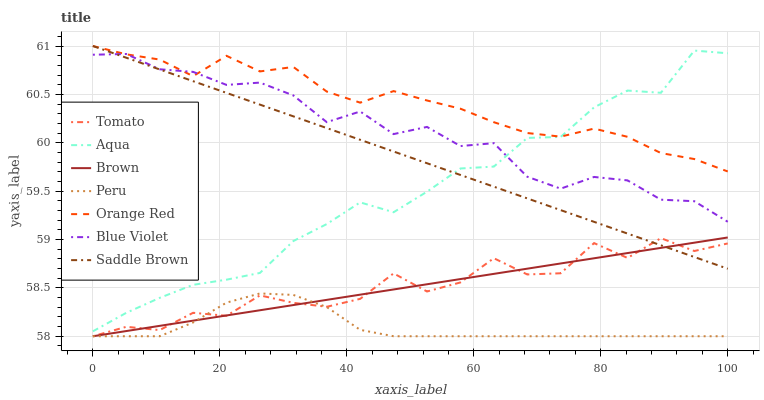Does Peru have the minimum area under the curve?
Answer yes or no. Yes. Does Orange Red have the maximum area under the curve?
Answer yes or no. Yes. Does Brown have the minimum area under the curve?
Answer yes or no. No. Does Brown have the maximum area under the curve?
Answer yes or no. No. Is Brown the smoothest?
Answer yes or no. Yes. Is Tomato the roughest?
Answer yes or no. Yes. Is Aqua the smoothest?
Answer yes or no. No. Is Aqua the roughest?
Answer yes or no. No. Does Tomato have the lowest value?
Answer yes or no. Yes. Does Aqua have the lowest value?
Answer yes or no. No. Does Orange Red have the highest value?
Answer yes or no. Yes. Does Brown have the highest value?
Answer yes or no. No. Is Tomato less than Blue Violet?
Answer yes or no. Yes. Is Aqua greater than Peru?
Answer yes or no. Yes. Does Saddle Brown intersect Aqua?
Answer yes or no. Yes. Is Saddle Brown less than Aqua?
Answer yes or no. No. Is Saddle Brown greater than Aqua?
Answer yes or no. No. Does Tomato intersect Blue Violet?
Answer yes or no. No. 